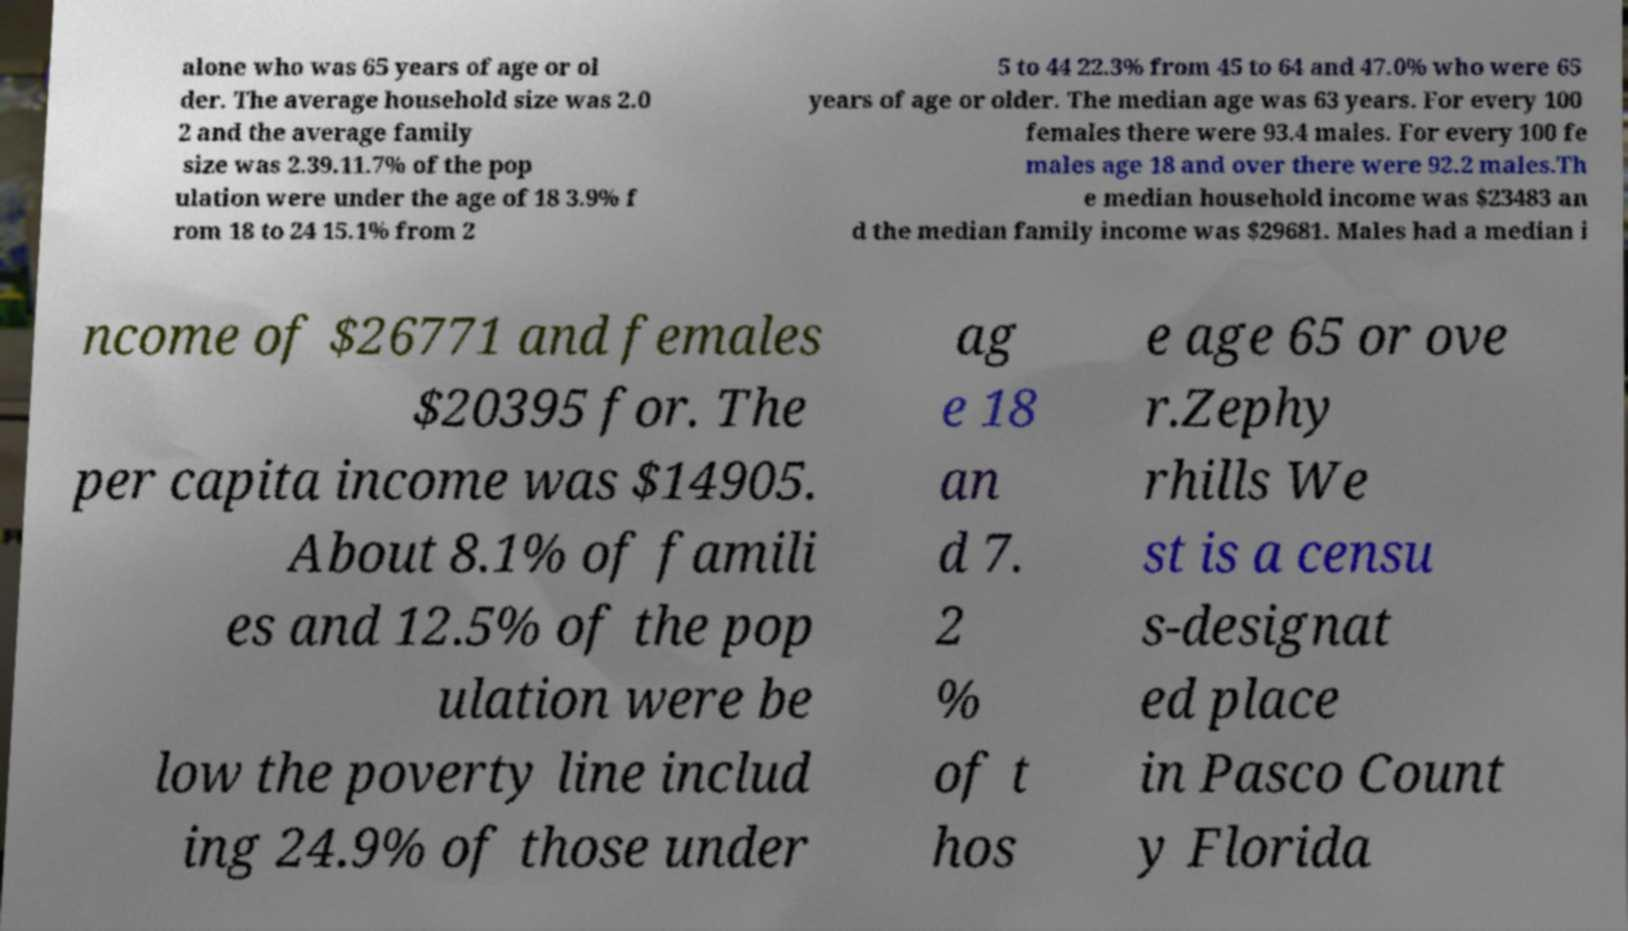Please read and relay the text visible in this image. What does it say? alone who was 65 years of age or ol der. The average household size was 2.0 2 and the average family size was 2.39.11.7% of the pop ulation were under the age of 18 3.9% f rom 18 to 24 15.1% from 2 5 to 44 22.3% from 45 to 64 and 47.0% who were 65 years of age or older. The median age was 63 years. For every 100 females there were 93.4 males. For every 100 fe males age 18 and over there were 92.2 males.Th e median household income was $23483 an d the median family income was $29681. Males had a median i ncome of $26771 and females $20395 for. The per capita income was $14905. About 8.1% of famili es and 12.5% of the pop ulation were be low the poverty line includ ing 24.9% of those under ag e 18 an d 7. 2 % of t hos e age 65 or ove r.Zephy rhills We st is a censu s-designat ed place in Pasco Count y Florida 